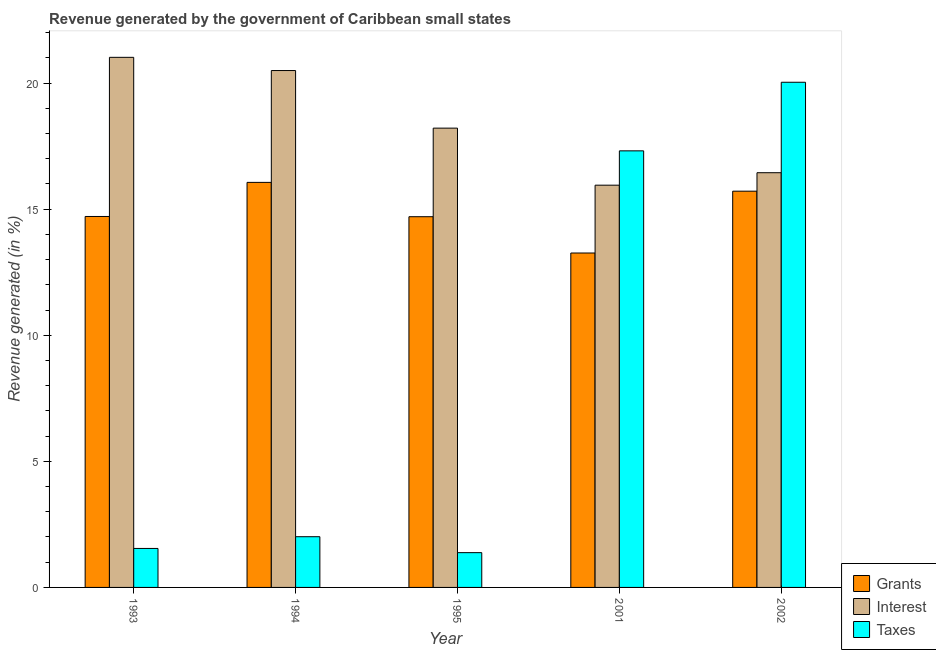Are the number of bars per tick equal to the number of legend labels?
Your response must be concise. Yes. Are the number of bars on each tick of the X-axis equal?
Make the answer very short. Yes. How many bars are there on the 2nd tick from the left?
Offer a very short reply. 3. In how many cases, is the number of bars for a given year not equal to the number of legend labels?
Provide a short and direct response. 0. What is the percentage of revenue generated by interest in 1995?
Offer a terse response. 18.21. Across all years, what is the maximum percentage of revenue generated by grants?
Make the answer very short. 16.06. Across all years, what is the minimum percentage of revenue generated by taxes?
Ensure brevity in your answer.  1.38. In which year was the percentage of revenue generated by grants minimum?
Offer a terse response. 2001. What is the total percentage of revenue generated by grants in the graph?
Make the answer very short. 74.44. What is the difference between the percentage of revenue generated by taxes in 1993 and that in 2002?
Keep it short and to the point. -18.49. What is the difference between the percentage of revenue generated by grants in 1993 and the percentage of revenue generated by taxes in 1994?
Ensure brevity in your answer.  -1.35. What is the average percentage of revenue generated by interest per year?
Offer a very short reply. 18.42. In how many years, is the percentage of revenue generated by grants greater than 2 %?
Your answer should be very brief. 5. What is the ratio of the percentage of revenue generated by taxes in 1994 to that in 1995?
Give a very brief answer. 1.46. Is the percentage of revenue generated by grants in 1995 less than that in 2001?
Ensure brevity in your answer.  No. Is the difference between the percentage of revenue generated by taxes in 1993 and 1994 greater than the difference between the percentage of revenue generated by interest in 1993 and 1994?
Offer a very short reply. No. What is the difference between the highest and the second highest percentage of revenue generated by interest?
Keep it short and to the point. 0.52. What is the difference between the highest and the lowest percentage of revenue generated by grants?
Keep it short and to the point. 2.8. Is the sum of the percentage of revenue generated by interest in 1994 and 2001 greater than the maximum percentage of revenue generated by taxes across all years?
Offer a very short reply. Yes. What does the 2nd bar from the left in 2002 represents?
Give a very brief answer. Interest. What does the 3rd bar from the right in 2001 represents?
Offer a terse response. Grants. How many years are there in the graph?
Keep it short and to the point. 5. What is the difference between two consecutive major ticks on the Y-axis?
Make the answer very short. 5. Does the graph contain any zero values?
Offer a very short reply. No. Where does the legend appear in the graph?
Offer a terse response. Bottom right. How many legend labels are there?
Keep it short and to the point. 3. How are the legend labels stacked?
Offer a very short reply. Vertical. What is the title of the graph?
Your answer should be compact. Revenue generated by the government of Caribbean small states. What is the label or title of the X-axis?
Ensure brevity in your answer.  Year. What is the label or title of the Y-axis?
Provide a short and direct response. Revenue generated (in %). What is the Revenue generated (in %) of Grants in 1993?
Provide a short and direct response. 14.71. What is the Revenue generated (in %) in Interest in 1993?
Make the answer very short. 21.02. What is the Revenue generated (in %) of Taxes in 1993?
Your answer should be very brief. 1.55. What is the Revenue generated (in %) of Grants in 1994?
Make the answer very short. 16.06. What is the Revenue generated (in %) in Interest in 1994?
Ensure brevity in your answer.  20.5. What is the Revenue generated (in %) of Taxes in 1994?
Make the answer very short. 2.01. What is the Revenue generated (in %) of Grants in 1995?
Provide a short and direct response. 14.7. What is the Revenue generated (in %) of Interest in 1995?
Make the answer very short. 18.21. What is the Revenue generated (in %) in Taxes in 1995?
Keep it short and to the point. 1.38. What is the Revenue generated (in %) in Grants in 2001?
Provide a succinct answer. 13.26. What is the Revenue generated (in %) in Interest in 2001?
Keep it short and to the point. 15.95. What is the Revenue generated (in %) in Taxes in 2001?
Keep it short and to the point. 17.31. What is the Revenue generated (in %) of Grants in 2002?
Ensure brevity in your answer.  15.71. What is the Revenue generated (in %) in Interest in 2002?
Your answer should be very brief. 16.44. What is the Revenue generated (in %) of Taxes in 2002?
Make the answer very short. 20.03. Across all years, what is the maximum Revenue generated (in %) of Grants?
Your answer should be compact. 16.06. Across all years, what is the maximum Revenue generated (in %) in Interest?
Make the answer very short. 21.02. Across all years, what is the maximum Revenue generated (in %) in Taxes?
Your answer should be very brief. 20.03. Across all years, what is the minimum Revenue generated (in %) in Grants?
Keep it short and to the point. 13.26. Across all years, what is the minimum Revenue generated (in %) in Interest?
Offer a very short reply. 15.95. Across all years, what is the minimum Revenue generated (in %) of Taxes?
Offer a very short reply. 1.38. What is the total Revenue generated (in %) in Grants in the graph?
Give a very brief answer. 74.44. What is the total Revenue generated (in %) in Interest in the graph?
Your answer should be very brief. 92.12. What is the total Revenue generated (in %) of Taxes in the graph?
Your response must be concise. 42.28. What is the difference between the Revenue generated (in %) of Grants in 1993 and that in 1994?
Offer a very short reply. -1.35. What is the difference between the Revenue generated (in %) in Interest in 1993 and that in 1994?
Your answer should be very brief. 0.52. What is the difference between the Revenue generated (in %) in Taxes in 1993 and that in 1994?
Offer a very short reply. -0.46. What is the difference between the Revenue generated (in %) in Grants in 1993 and that in 1995?
Offer a terse response. 0.01. What is the difference between the Revenue generated (in %) of Interest in 1993 and that in 1995?
Your answer should be very brief. 2.81. What is the difference between the Revenue generated (in %) of Taxes in 1993 and that in 1995?
Ensure brevity in your answer.  0.17. What is the difference between the Revenue generated (in %) in Grants in 1993 and that in 2001?
Keep it short and to the point. 1.45. What is the difference between the Revenue generated (in %) of Interest in 1993 and that in 2001?
Your answer should be very brief. 5.07. What is the difference between the Revenue generated (in %) of Taxes in 1993 and that in 2001?
Your answer should be very brief. -15.77. What is the difference between the Revenue generated (in %) in Grants in 1993 and that in 2002?
Provide a short and direct response. -1. What is the difference between the Revenue generated (in %) of Interest in 1993 and that in 2002?
Offer a terse response. 4.58. What is the difference between the Revenue generated (in %) in Taxes in 1993 and that in 2002?
Provide a succinct answer. -18.49. What is the difference between the Revenue generated (in %) in Grants in 1994 and that in 1995?
Your answer should be very brief. 1.36. What is the difference between the Revenue generated (in %) of Interest in 1994 and that in 1995?
Offer a very short reply. 2.28. What is the difference between the Revenue generated (in %) in Taxes in 1994 and that in 1995?
Your answer should be compact. 0.63. What is the difference between the Revenue generated (in %) of Grants in 1994 and that in 2001?
Make the answer very short. 2.8. What is the difference between the Revenue generated (in %) of Interest in 1994 and that in 2001?
Give a very brief answer. 4.55. What is the difference between the Revenue generated (in %) in Taxes in 1994 and that in 2001?
Your response must be concise. -15.3. What is the difference between the Revenue generated (in %) in Grants in 1994 and that in 2002?
Your answer should be compact. 0.35. What is the difference between the Revenue generated (in %) in Interest in 1994 and that in 2002?
Offer a terse response. 4.05. What is the difference between the Revenue generated (in %) of Taxes in 1994 and that in 2002?
Provide a short and direct response. -18.02. What is the difference between the Revenue generated (in %) in Grants in 1995 and that in 2001?
Your answer should be very brief. 1.44. What is the difference between the Revenue generated (in %) of Interest in 1995 and that in 2001?
Provide a succinct answer. 2.26. What is the difference between the Revenue generated (in %) in Taxes in 1995 and that in 2001?
Provide a short and direct response. -15.93. What is the difference between the Revenue generated (in %) of Grants in 1995 and that in 2002?
Give a very brief answer. -1.01. What is the difference between the Revenue generated (in %) of Interest in 1995 and that in 2002?
Give a very brief answer. 1.77. What is the difference between the Revenue generated (in %) in Taxes in 1995 and that in 2002?
Keep it short and to the point. -18.65. What is the difference between the Revenue generated (in %) of Grants in 2001 and that in 2002?
Offer a terse response. -2.45. What is the difference between the Revenue generated (in %) in Interest in 2001 and that in 2002?
Your response must be concise. -0.49. What is the difference between the Revenue generated (in %) of Taxes in 2001 and that in 2002?
Offer a terse response. -2.72. What is the difference between the Revenue generated (in %) in Grants in 1993 and the Revenue generated (in %) in Interest in 1994?
Your answer should be very brief. -5.79. What is the difference between the Revenue generated (in %) in Grants in 1993 and the Revenue generated (in %) in Taxes in 1994?
Provide a succinct answer. 12.7. What is the difference between the Revenue generated (in %) in Interest in 1993 and the Revenue generated (in %) in Taxes in 1994?
Your answer should be compact. 19.01. What is the difference between the Revenue generated (in %) of Grants in 1993 and the Revenue generated (in %) of Interest in 1995?
Provide a succinct answer. -3.5. What is the difference between the Revenue generated (in %) in Grants in 1993 and the Revenue generated (in %) in Taxes in 1995?
Give a very brief answer. 13.33. What is the difference between the Revenue generated (in %) in Interest in 1993 and the Revenue generated (in %) in Taxes in 1995?
Give a very brief answer. 19.64. What is the difference between the Revenue generated (in %) in Grants in 1993 and the Revenue generated (in %) in Interest in 2001?
Keep it short and to the point. -1.24. What is the difference between the Revenue generated (in %) of Grants in 1993 and the Revenue generated (in %) of Taxes in 2001?
Give a very brief answer. -2.6. What is the difference between the Revenue generated (in %) of Interest in 1993 and the Revenue generated (in %) of Taxes in 2001?
Keep it short and to the point. 3.71. What is the difference between the Revenue generated (in %) in Grants in 1993 and the Revenue generated (in %) in Interest in 2002?
Provide a succinct answer. -1.74. What is the difference between the Revenue generated (in %) in Grants in 1993 and the Revenue generated (in %) in Taxes in 2002?
Your response must be concise. -5.32. What is the difference between the Revenue generated (in %) of Interest in 1993 and the Revenue generated (in %) of Taxes in 2002?
Ensure brevity in your answer.  0.99. What is the difference between the Revenue generated (in %) of Grants in 1994 and the Revenue generated (in %) of Interest in 1995?
Your answer should be compact. -2.15. What is the difference between the Revenue generated (in %) in Grants in 1994 and the Revenue generated (in %) in Taxes in 1995?
Provide a succinct answer. 14.68. What is the difference between the Revenue generated (in %) of Interest in 1994 and the Revenue generated (in %) of Taxes in 1995?
Provide a succinct answer. 19.12. What is the difference between the Revenue generated (in %) of Grants in 1994 and the Revenue generated (in %) of Interest in 2001?
Give a very brief answer. 0.11. What is the difference between the Revenue generated (in %) in Grants in 1994 and the Revenue generated (in %) in Taxes in 2001?
Provide a succinct answer. -1.25. What is the difference between the Revenue generated (in %) of Interest in 1994 and the Revenue generated (in %) of Taxes in 2001?
Ensure brevity in your answer.  3.18. What is the difference between the Revenue generated (in %) in Grants in 1994 and the Revenue generated (in %) in Interest in 2002?
Give a very brief answer. -0.38. What is the difference between the Revenue generated (in %) in Grants in 1994 and the Revenue generated (in %) in Taxes in 2002?
Offer a very short reply. -3.97. What is the difference between the Revenue generated (in %) of Interest in 1994 and the Revenue generated (in %) of Taxes in 2002?
Give a very brief answer. 0.46. What is the difference between the Revenue generated (in %) in Grants in 1995 and the Revenue generated (in %) in Interest in 2001?
Provide a succinct answer. -1.25. What is the difference between the Revenue generated (in %) in Grants in 1995 and the Revenue generated (in %) in Taxes in 2001?
Keep it short and to the point. -2.61. What is the difference between the Revenue generated (in %) in Interest in 1995 and the Revenue generated (in %) in Taxes in 2001?
Ensure brevity in your answer.  0.9. What is the difference between the Revenue generated (in %) of Grants in 1995 and the Revenue generated (in %) of Interest in 2002?
Provide a short and direct response. -1.74. What is the difference between the Revenue generated (in %) of Grants in 1995 and the Revenue generated (in %) of Taxes in 2002?
Make the answer very short. -5.33. What is the difference between the Revenue generated (in %) in Interest in 1995 and the Revenue generated (in %) in Taxes in 2002?
Provide a short and direct response. -1.82. What is the difference between the Revenue generated (in %) in Grants in 2001 and the Revenue generated (in %) in Interest in 2002?
Make the answer very short. -3.18. What is the difference between the Revenue generated (in %) in Grants in 2001 and the Revenue generated (in %) in Taxes in 2002?
Keep it short and to the point. -6.77. What is the difference between the Revenue generated (in %) in Interest in 2001 and the Revenue generated (in %) in Taxes in 2002?
Your answer should be very brief. -4.08. What is the average Revenue generated (in %) in Grants per year?
Ensure brevity in your answer.  14.89. What is the average Revenue generated (in %) in Interest per year?
Your answer should be very brief. 18.42. What is the average Revenue generated (in %) in Taxes per year?
Offer a very short reply. 8.46. In the year 1993, what is the difference between the Revenue generated (in %) in Grants and Revenue generated (in %) in Interest?
Offer a very short reply. -6.31. In the year 1993, what is the difference between the Revenue generated (in %) of Grants and Revenue generated (in %) of Taxes?
Ensure brevity in your answer.  13.16. In the year 1993, what is the difference between the Revenue generated (in %) in Interest and Revenue generated (in %) in Taxes?
Provide a short and direct response. 19.47. In the year 1994, what is the difference between the Revenue generated (in %) in Grants and Revenue generated (in %) in Interest?
Offer a terse response. -4.43. In the year 1994, what is the difference between the Revenue generated (in %) in Grants and Revenue generated (in %) in Taxes?
Your answer should be very brief. 14.05. In the year 1994, what is the difference between the Revenue generated (in %) in Interest and Revenue generated (in %) in Taxes?
Ensure brevity in your answer.  18.49. In the year 1995, what is the difference between the Revenue generated (in %) of Grants and Revenue generated (in %) of Interest?
Offer a terse response. -3.51. In the year 1995, what is the difference between the Revenue generated (in %) of Grants and Revenue generated (in %) of Taxes?
Offer a terse response. 13.32. In the year 1995, what is the difference between the Revenue generated (in %) of Interest and Revenue generated (in %) of Taxes?
Your response must be concise. 16.83. In the year 2001, what is the difference between the Revenue generated (in %) of Grants and Revenue generated (in %) of Interest?
Your answer should be very brief. -2.69. In the year 2001, what is the difference between the Revenue generated (in %) in Grants and Revenue generated (in %) in Taxes?
Make the answer very short. -4.05. In the year 2001, what is the difference between the Revenue generated (in %) in Interest and Revenue generated (in %) in Taxes?
Your answer should be compact. -1.36. In the year 2002, what is the difference between the Revenue generated (in %) in Grants and Revenue generated (in %) in Interest?
Make the answer very short. -0.73. In the year 2002, what is the difference between the Revenue generated (in %) of Grants and Revenue generated (in %) of Taxes?
Make the answer very short. -4.32. In the year 2002, what is the difference between the Revenue generated (in %) in Interest and Revenue generated (in %) in Taxes?
Ensure brevity in your answer.  -3.59. What is the ratio of the Revenue generated (in %) in Grants in 1993 to that in 1994?
Your response must be concise. 0.92. What is the ratio of the Revenue generated (in %) of Interest in 1993 to that in 1994?
Make the answer very short. 1.03. What is the ratio of the Revenue generated (in %) in Taxes in 1993 to that in 1994?
Offer a terse response. 0.77. What is the ratio of the Revenue generated (in %) in Interest in 1993 to that in 1995?
Provide a short and direct response. 1.15. What is the ratio of the Revenue generated (in %) of Taxes in 1993 to that in 1995?
Your response must be concise. 1.12. What is the ratio of the Revenue generated (in %) in Grants in 1993 to that in 2001?
Your response must be concise. 1.11. What is the ratio of the Revenue generated (in %) in Interest in 1993 to that in 2001?
Provide a short and direct response. 1.32. What is the ratio of the Revenue generated (in %) in Taxes in 1993 to that in 2001?
Offer a terse response. 0.09. What is the ratio of the Revenue generated (in %) in Grants in 1993 to that in 2002?
Give a very brief answer. 0.94. What is the ratio of the Revenue generated (in %) of Interest in 1993 to that in 2002?
Make the answer very short. 1.28. What is the ratio of the Revenue generated (in %) of Taxes in 1993 to that in 2002?
Provide a succinct answer. 0.08. What is the ratio of the Revenue generated (in %) in Grants in 1994 to that in 1995?
Offer a very short reply. 1.09. What is the ratio of the Revenue generated (in %) of Interest in 1994 to that in 1995?
Your response must be concise. 1.13. What is the ratio of the Revenue generated (in %) of Taxes in 1994 to that in 1995?
Give a very brief answer. 1.46. What is the ratio of the Revenue generated (in %) in Grants in 1994 to that in 2001?
Your answer should be very brief. 1.21. What is the ratio of the Revenue generated (in %) in Interest in 1994 to that in 2001?
Your answer should be very brief. 1.28. What is the ratio of the Revenue generated (in %) in Taxes in 1994 to that in 2001?
Ensure brevity in your answer.  0.12. What is the ratio of the Revenue generated (in %) in Grants in 1994 to that in 2002?
Your response must be concise. 1.02. What is the ratio of the Revenue generated (in %) in Interest in 1994 to that in 2002?
Give a very brief answer. 1.25. What is the ratio of the Revenue generated (in %) in Taxes in 1994 to that in 2002?
Give a very brief answer. 0.1. What is the ratio of the Revenue generated (in %) in Grants in 1995 to that in 2001?
Offer a very short reply. 1.11. What is the ratio of the Revenue generated (in %) of Interest in 1995 to that in 2001?
Your answer should be very brief. 1.14. What is the ratio of the Revenue generated (in %) in Taxes in 1995 to that in 2001?
Ensure brevity in your answer.  0.08. What is the ratio of the Revenue generated (in %) in Grants in 1995 to that in 2002?
Your answer should be compact. 0.94. What is the ratio of the Revenue generated (in %) of Interest in 1995 to that in 2002?
Your answer should be very brief. 1.11. What is the ratio of the Revenue generated (in %) in Taxes in 1995 to that in 2002?
Offer a terse response. 0.07. What is the ratio of the Revenue generated (in %) of Grants in 2001 to that in 2002?
Make the answer very short. 0.84. What is the ratio of the Revenue generated (in %) of Interest in 2001 to that in 2002?
Offer a very short reply. 0.97. What is the ratio of the Revenue generated (in %) of Taxes in 2001 to that in 2002?
Provide a short and direct response. 0.86. What is the difference between the highest and the second highest Revenue generated (in %) in Grants?
Your answer should be very brief. 0.35. What is the difference between the highest and the second highest Revenue generated (in %) of Interest?
Your answer should be very brief. 0.52. What is the difference between the highest and the second highest Revenue generated (in %) in Taxes?
Provide a succinct answer. 2.72. What is the difference between the highest and the lowest Revenue generated (in %) of Grants?
Give a very brief answer. 2.8. What is the difference between the highest and the lowest Revenue generated (in %) in Interest?
Provide a short and direct response. 5.07. What is the difference between the highest and the lowest Revenue generated (in %) of Taxes?
Give a very brief answer. 18.65. 